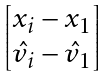Convert formula to latex. <formula><loc_0><loc_0><loc_500><loc_500>\begin{bmatrix} x _ { i } - x _ { 1 } \\ \hat { v } _ { i } - \hat { v } _ { 1 } \end{bmatrix}</formula> 